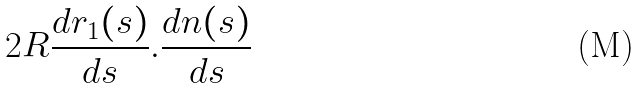Convert formula to latex. <formula><loc_0><loc_0><loc_500><loc_500>2 R \frac { d r _ { 1 } ( s ) } { d s } . \frac { d n ( s ) } { d s }</formula> 